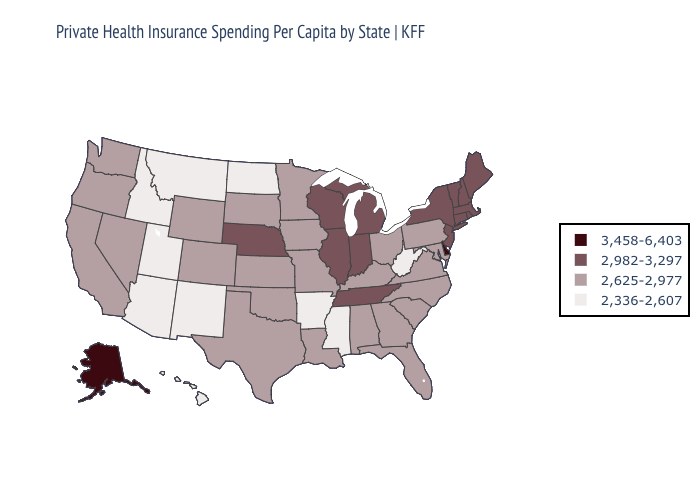Name the states that have a value in the range 3,458-6,403?
Keep it brief. Alaska, Delaware. What is the value of Washington?
Write a very short answer. 2,625-2,977. What is the highest value in the Northeast ?
Be succinct. 2,982-3,297. What is the highest value in states that border Alabama?
Write a very short answer. 2,982-3,297. What is the value of Pennsylvania?
Quick response, please. 2,625-2,977. Does Alaska have the highest value in the USA?
Give a very brief answer. Yes. Among the states that border Oklahoma , does Arkansas have the highest value?
Answer briefly. No. Among the states that border Louisiana , does Texas have the highest value?
Concise answer only. Yes. What is the lowest value in the USA?
Keep it brief. 2,336-2,607. Does Massachusetts have a higher value than Arizona?
Quick response, please. Yes. What is the lowest value in the USA?
Answer briefly. 2,336-2,607. What is the value of Montana?
Answer briefly. 2,336-2,607. Which states have the lowest value in the USA?
Concise answer only. Arizona, Arkansas, Hawaii, Idaho, Mississippi, Montana, New Mexico, North Dakota, Utah, West Virginia. Name the states that have a value in the range 2,336-2,607?
Be succinct. Arizona, Arkansas, Hawaii, Idaho, Mississippi, Montana, New Mexico, North Dakota, Utah, West Virginia. 